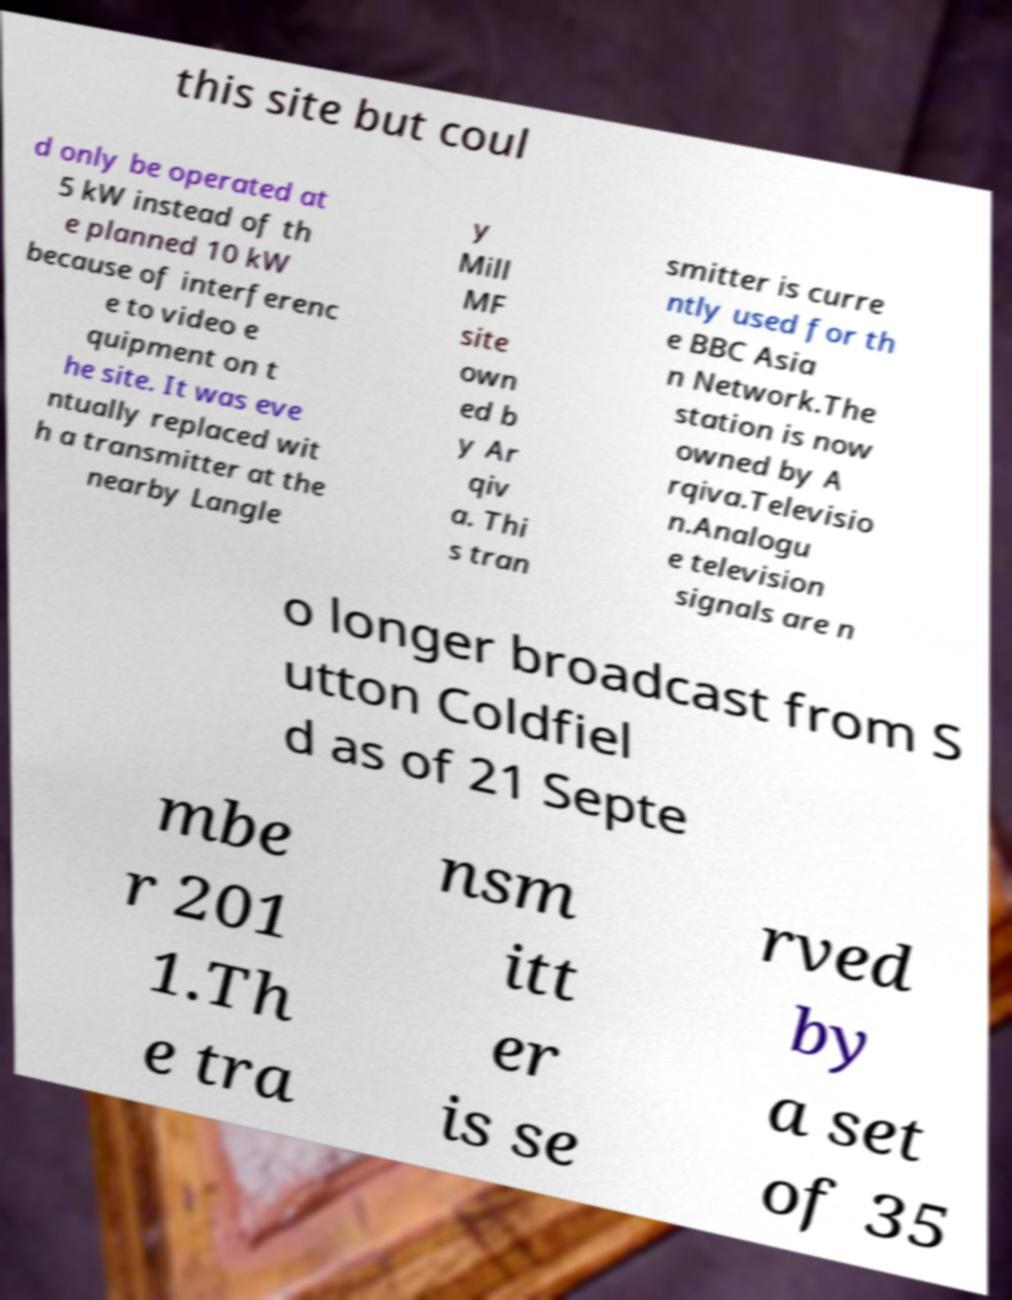I need the written content from this picture converted into text. Can you do that? this site but coul d only be operated at 5 kW instead of th e planned 10 kW because of interferenc e to video e quipment on t he site. It was eve ntually replaced wit h a transmitter at the nearby Langle y Mill MF site own ed b y Ar qiv a. Thi s tran smitter is curre ntly used for th e BBC Asia n Network.The station is now owned by A rqiva.Televisio n.Analogu e television signals are n o longer broadcast from S utton Coldfiel d as of 21 Septe mbe r 201 1.Th e tra nsm itt er is se rved by a set of 35 